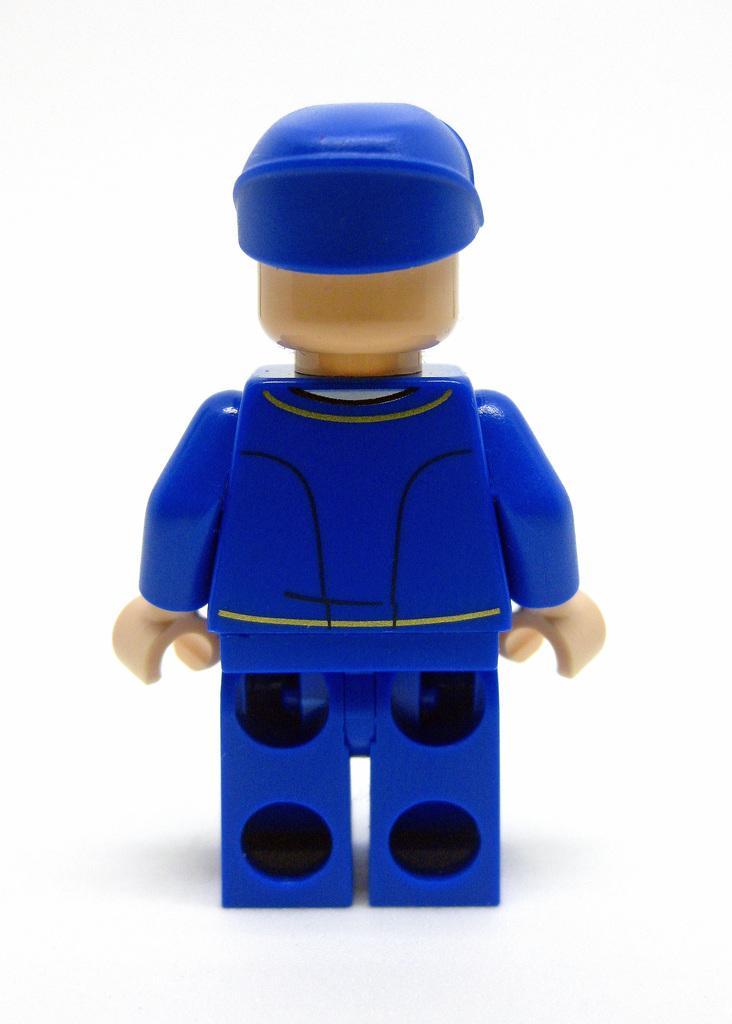Could you give a brief overview of what you see in this image? In this picture we can observe blue color toy. There is a cream color head and hands. The background is in white color. 